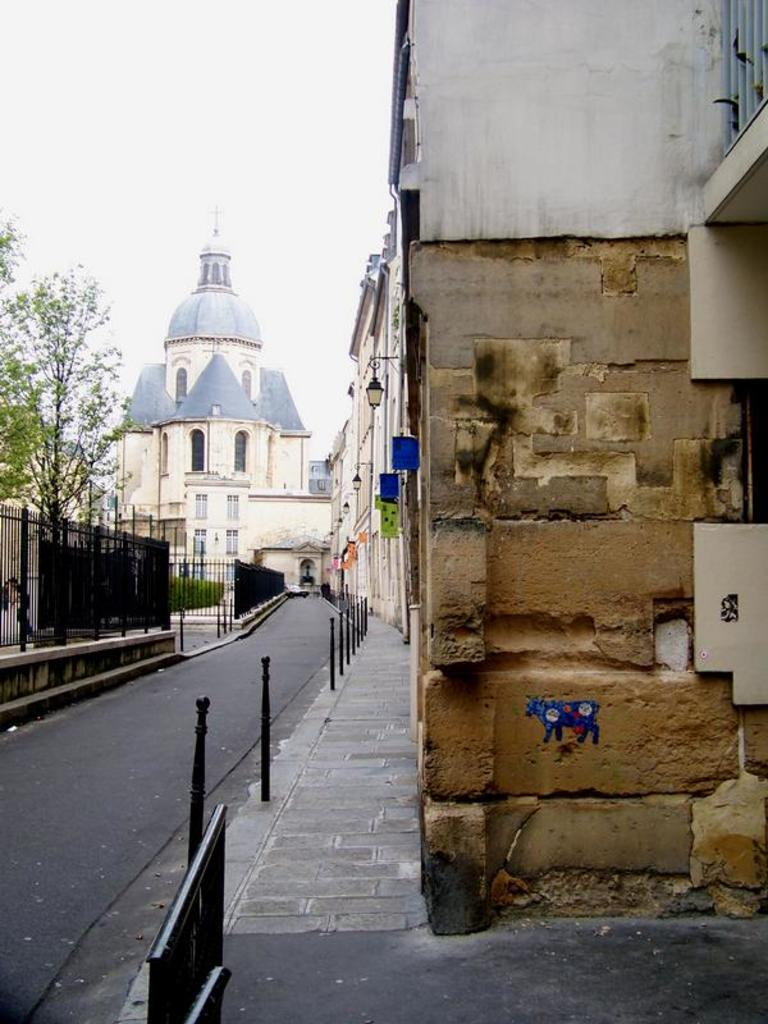What type of structures can be seen in the image? There are buildings with windows in the image. What is the purpose of the fence in the image? The purpose of the fence in the image is not explicitly stated, but it could be used for separating or enclosing areas. What type of vegetation is present in the image? There are trees in the image. What is the surface that vehicles might travel on in the image? There is a road in the image. What can be seen in the background of the image? The sky is visible in the background of the image. What direction is the governor walking in the image? There is no governor present in the image, so it is not possible to answer this question. 